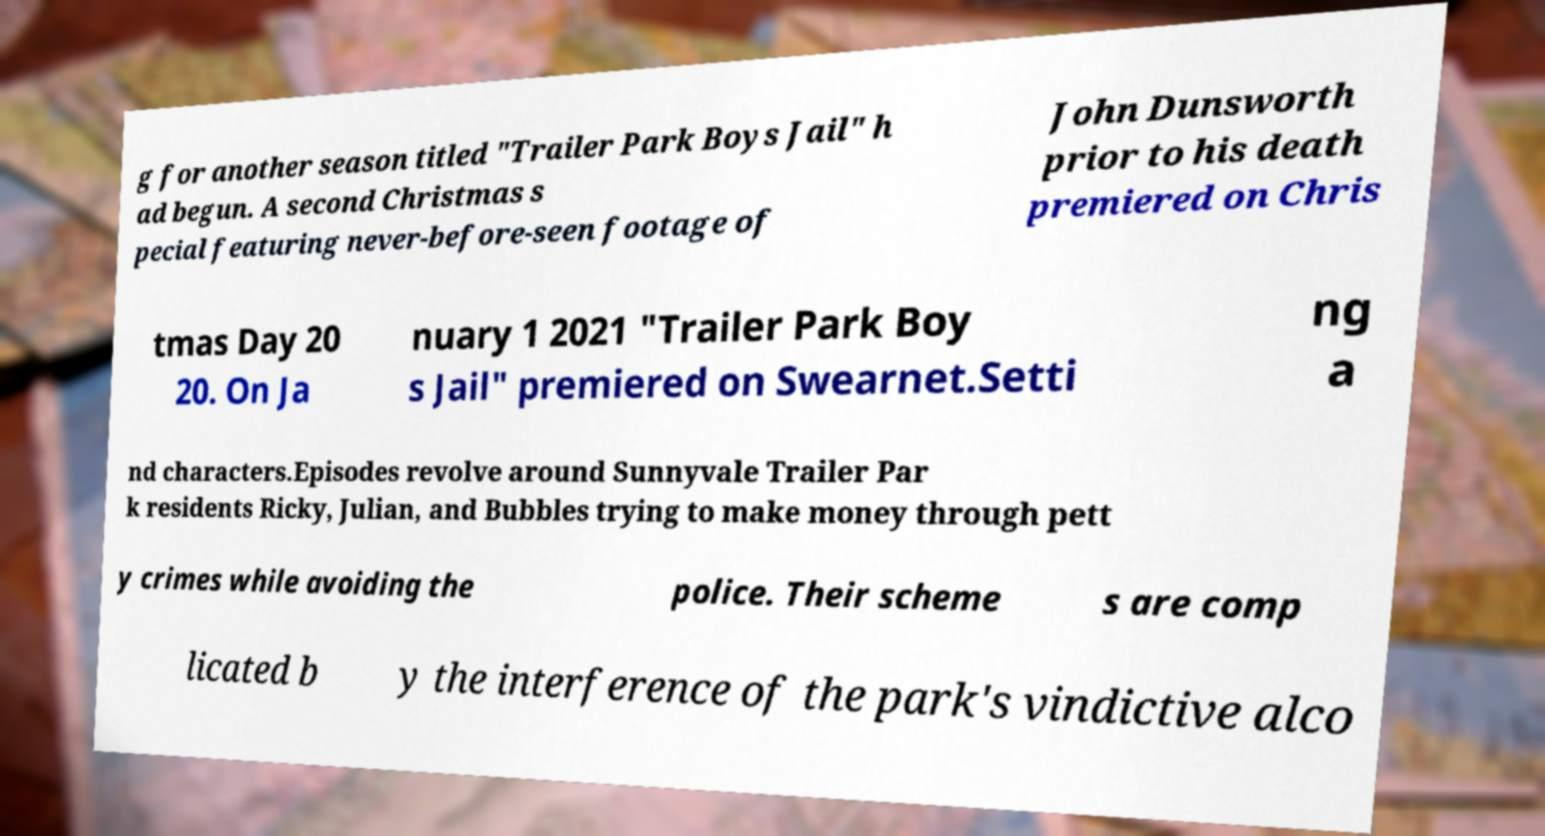Could you assist in decoding the text presented in this image and type it out clearly? g for another season titled "Trailer Park Boys Jail" h ad begun. A second Christmas s pecial featuring never-before-seen footage of John Dunsworth prior to his death premiered on Chris tmas Day 20 20. On Ja nuary 1 2021 "Trailer Park Boy s Jail" premiered on Swearnet.Setti ng a nd characters.Episodes revolve around Sunnyvale Trailer Par k residents Ricky, Julian, and Bubbles trying to make money through pett y crimes while avoiding the police. Their scheme s are comp licated b y the interference of the park's vindictive alco 